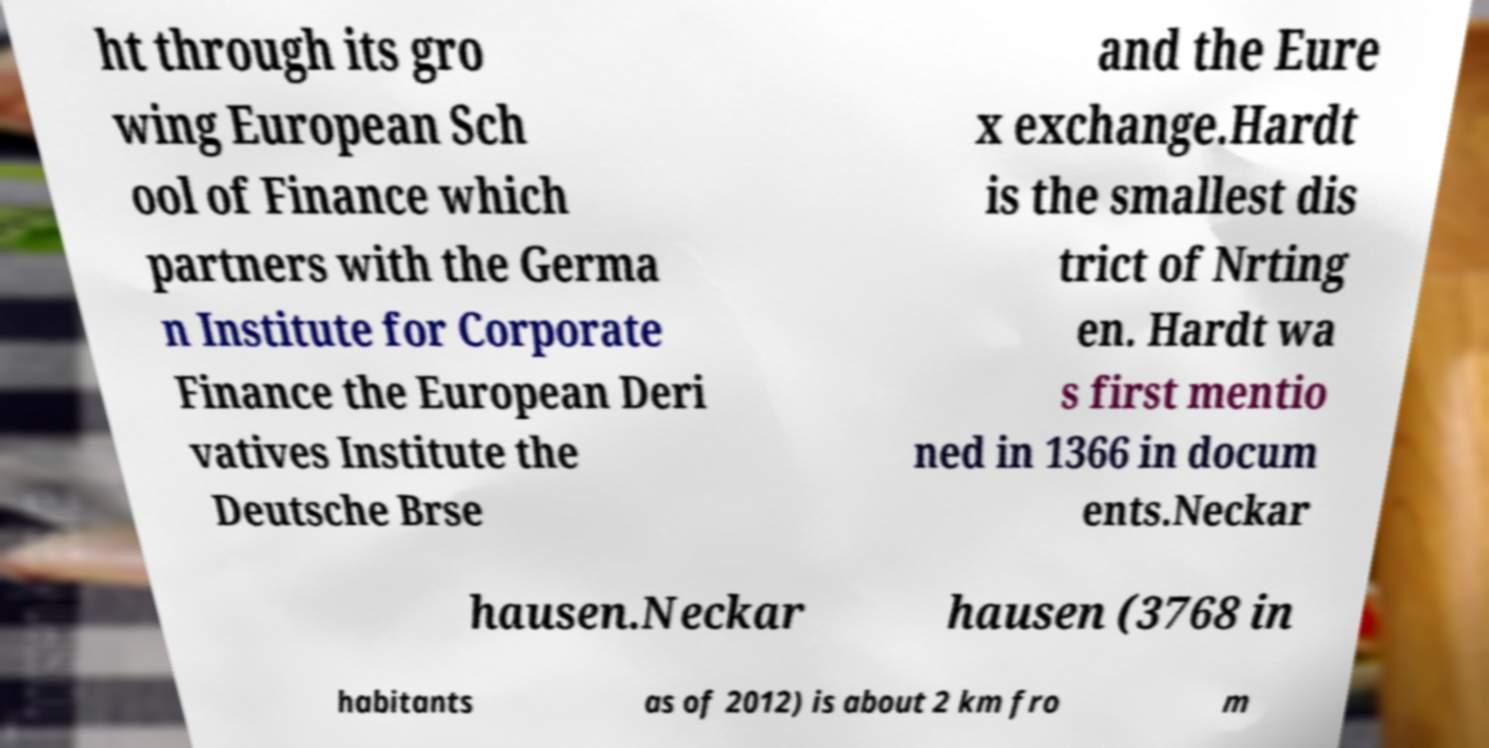For documentation purposes, I need the text within this image transcribed. Could you provide that? ht through its gro wing European Sch ool of Finance which partners with the Germa n Institute for Corporate Finance the European Deri vatives Institute the Deutsche Brse and the Eure x exchange.Hardt is the smallest dis trict of Nrting en. Hardt wa s first mentio ned in 1366 in docum ents.Neckar hausen.Neckar hausen (3768 in habitants as of 2012) is about 2 km fro m 